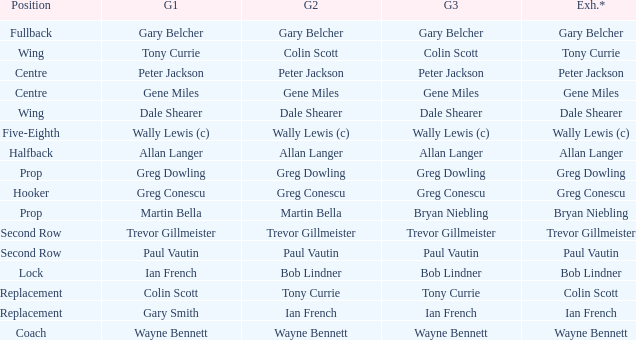What position has colin scott as game 1? Replacement. 